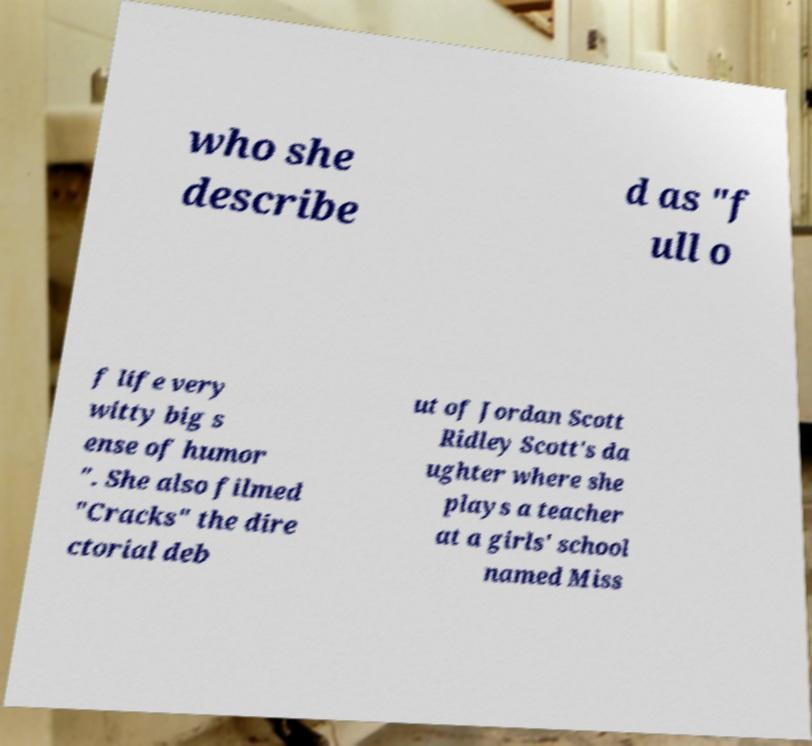Can you read and provide the text displayed in the image?This photo seems to have some interesting text. Can you extract and type it out for me? who she describe d as "f ull o f life very witty big s ense of humor ". She also filmed "Cracks" the dire ctorial deb ut of Jordan Scott Ridley Scott's da ughter where she plays a teacher at a girls' school named Miss 